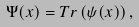<formula> <loc_0><loc_0><loc_500><loc_500>\Psi ( x ) = T r \left ( \psi ( x ) \right ) ,</formula> 